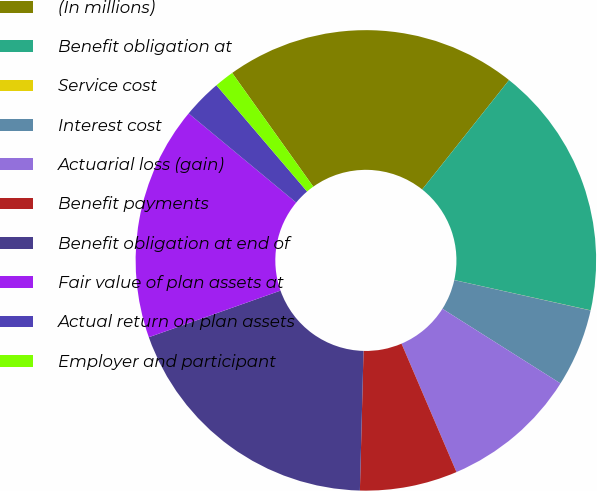Convert chart. <chart><loc_0><loc_0><loc_500><loc_500><pie_chart><fcel>(In millions)<fcel>Benefit obligation at<fcel>Service cost<fcel>Interest cost<fcel>Actuarial loss (gain)<fcel>Benefit payments<fcel>Benefit obligation at end of<fcel>Fair value of plan assets at<fcel>Actual return on plan assets<fcel>Employer and participant<nl><fcel>20.54%<fcel>17.8%<fcel>0.01%<fcel>5.48%<fcel>9.59%<fcel>6.85%<fcel>19.17%<fcel>16.43%<fcel>2.74%<fcel>1.38%<nl></chart> 